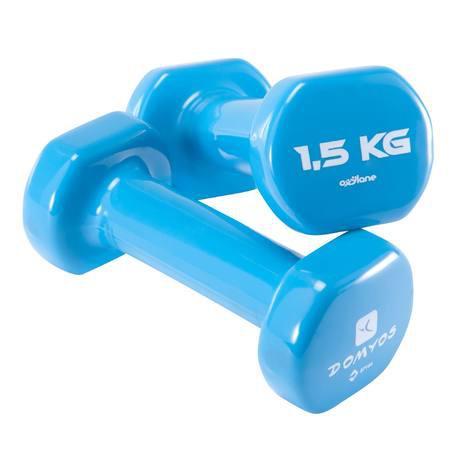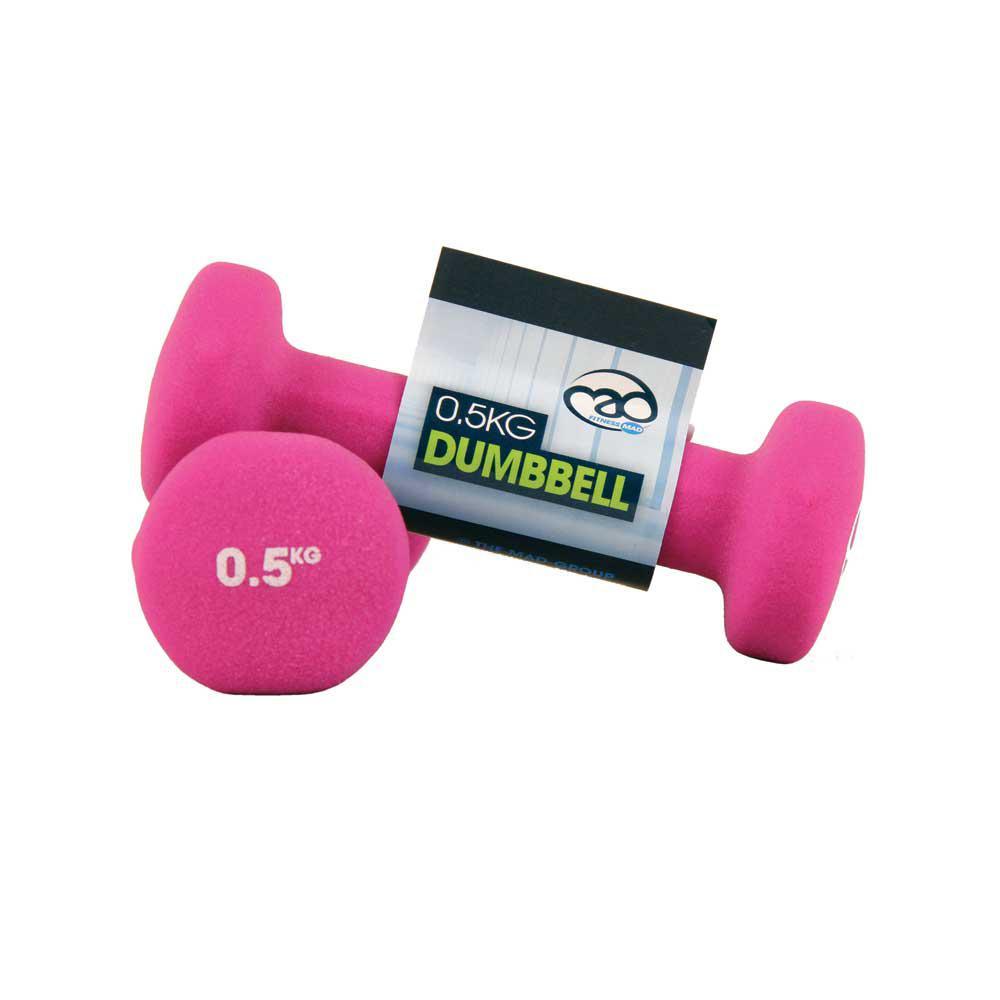The first image is the image on the left, the second image is the image on the right. Analyze the images presented: Is the assertion "In the image to the right, there is only one pair of free weights." valid? Answer yes or no. Yes. The first image is the image on the left, the second image is the image on the right. For the images displayed, is the sentence "There are two blue dumbbells." factually correct? Answer yes or no. Yes. 